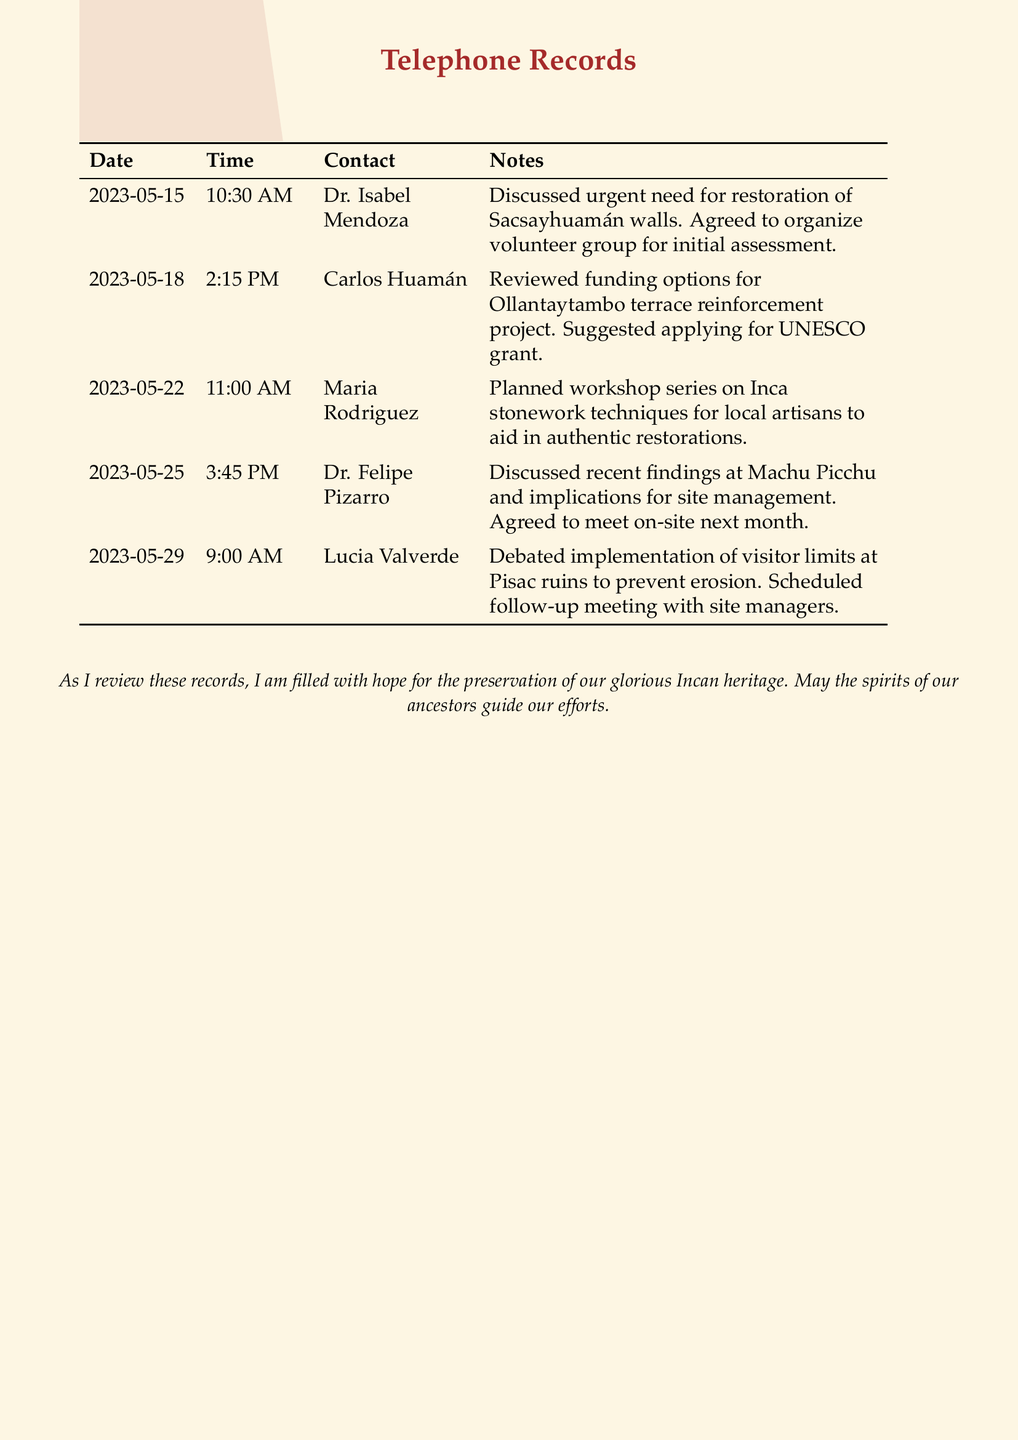What is the date of the first call? The first call recorded was on May 15, 2023.
Answer: May 15, 2023 Who did the second call involve? The second call was made to Carlos Huamán.
Answer: Carlos Huamán What was discussed in the call on May 22? The May 22 call involved planning a workshop series on Inca stonework techniques.
Answer: Workshop series on Inca stonework techniques How many calls were recorded in total? There are five calls recorded in the document.
Answer: 5 What was the primary focus of the conversation with Dr. Felipe Pizarro? The focus was on recent findings at Machu Picchu and site management implications.
Answer: Recent findings at Machu Picchu What action was agreed upon during the call with Dr. Isabel Mendoza? They agreed to organize a volunteer group for an initial assessment of Sacsayhuamán walls.
Answer: Organize volunteer group What is the main concern discussed about Pisac ruins? The concern was about preventing erosion by implementing visitor limits.
Answer: Erosion prevention What type of grant was suggested for the Ollantaytambo project? A UNESCO grant was suggested for funding options.
Answer: UNESCO grant What date is the follow-up meeting scheduled for the site managers? A follow-up meeting was scheduled but does not have a specific date mentioned.
Answer: Not specified 